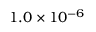<formula> <loc_0><loc_0><loc_500><loc_500>1 . 0 \times 1 0 ^ { - 6 }</formula> 